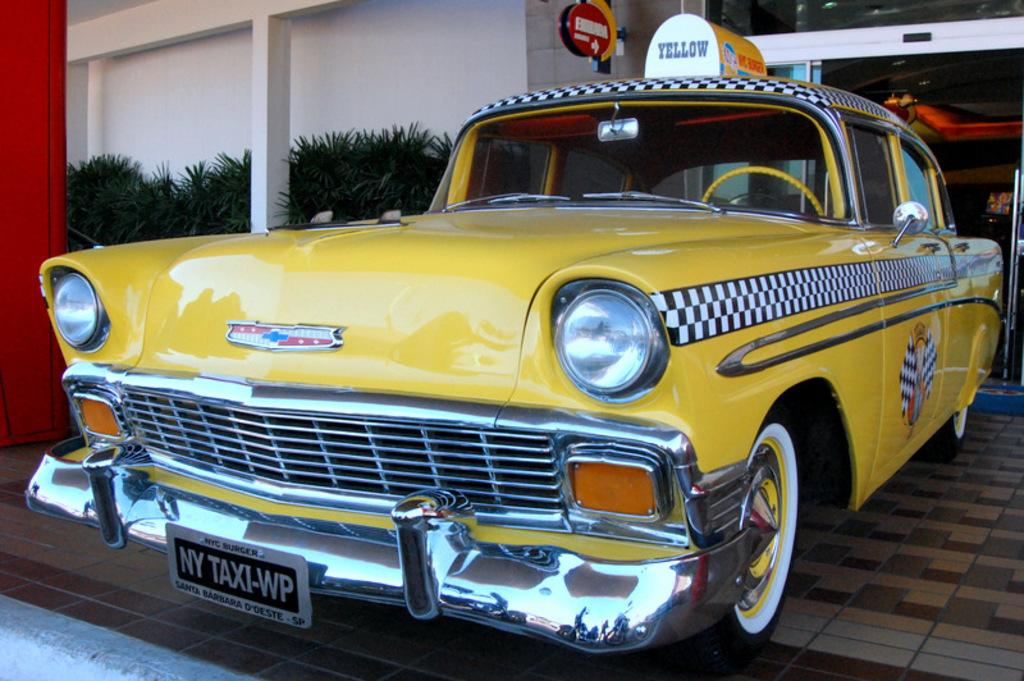Provide a one-sentence caption for the provided image. An old fashioned yellow taxi cab with black and white checkerboard from the fifties is parked on the sidewalk in front of a building. 